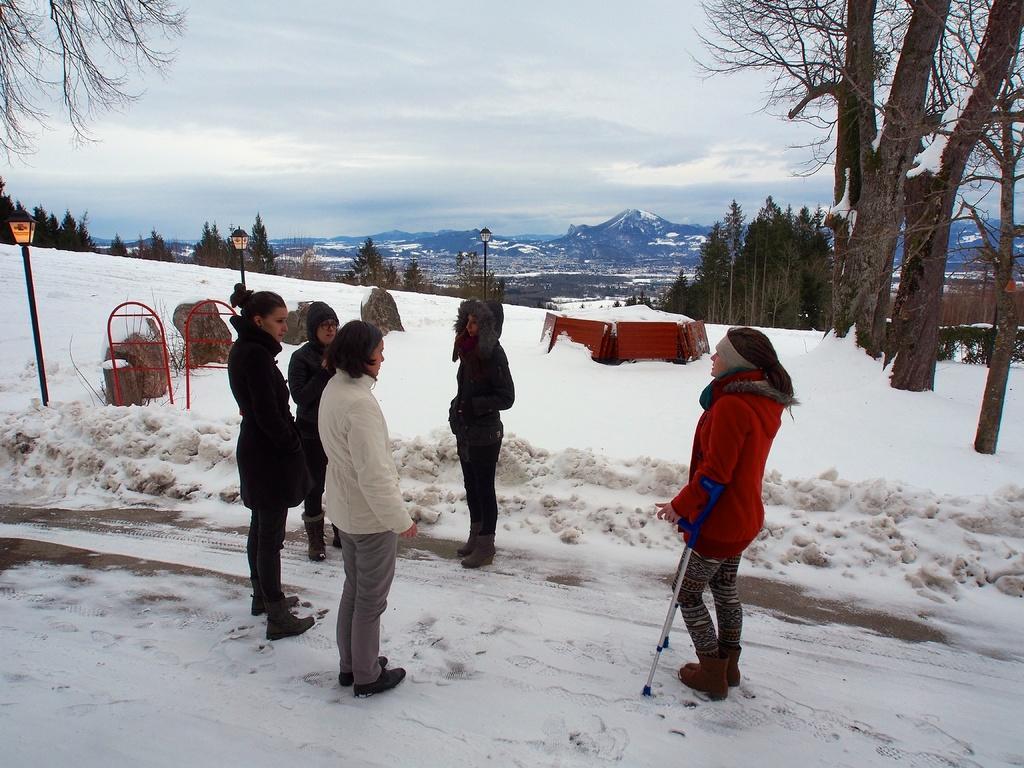Could you give a brief overview of what you see in this image? In the image we can see there are many people standing, wearing clothes and shoes. Everywhere there is a snow, white in color. These are the light poles, trees, mountains and a cloudy sky. 